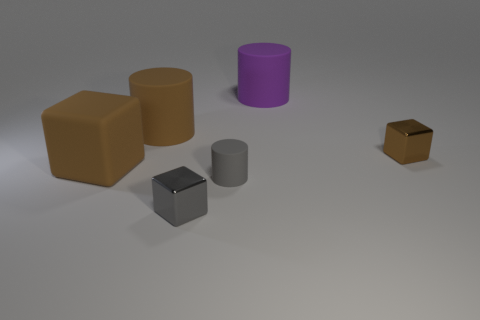Do the small cube that is on the right side of the large purple object and the matte cube have the same color?
Offer a terse response. Yes. What number of brown objects are large blocks or tiny cylinders?
Your answer should be compact. 1. Are the large thing that is in front of the small brown cube and the gray cube made of the same material?
Provide a succinct answer. No. How many things are either purple rubber things or rubber cylinders behind the large cube?
Keep it short and to the point. 2. There is a brown block on the left side of the large brown object that is to the right of the brown matte cube; what number of brown shiny cubes are right of it?
Your response must be concise. 1. Does the small gray thing that is in front of the gray cylinder have the same shape as the small gray rubber object?
Make the answer very short. No. There is a brown matte thing behind the brown metallic cube; is there a object that is right of it?
Your response must be concise. Yes. How many gray matte things are there?
Your answer should be very brief. 1. The block that is to the right of the big block and left of the purple matte cylinder is what color?
Your answer should be compact. Gray. There is a brown matte thing that is the same shape as the small gray shiny object; what size is it?
Keep it short and to the point. Large. 